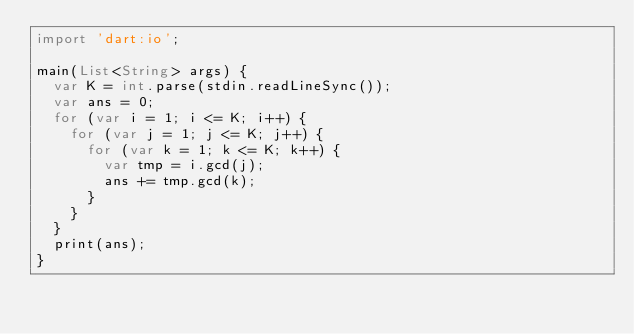Convert code to text. <code><loc_0><loc_0><loc_500><loc_500><_Dart_>import 'dart:io';

main(List<String> args) {
  var K = int.parse(stdin.readLineSync());
  var ans = 0;
  for (var i = 1; i <= K; i++) {
    for (var j = 1; j <= K; j++) {
      for (var k = 1; k <= K; k++) {
        var tmp = i.gcd(j);
        ans += tmp.gcd(k);
      }
    }
  }
  print(ans);
}
</code> 